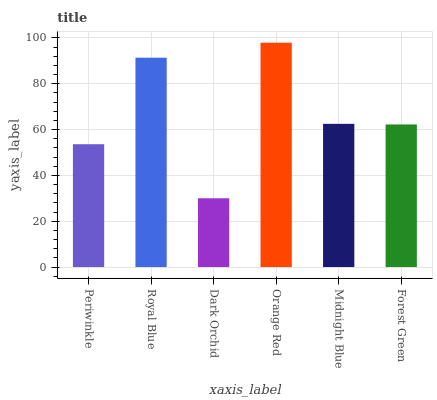Is Dark Orchid the minimum?
Answer yes or no. Yes. Is Orange Red the maximum?
Answer yes or no. Yes. Is Royal Blue the minimum?
Answer yes or no. No. Is Royal Blue the maximum?
Answer yes or no. No. Is Royal Blue greater than Periwinkle?
Answer yes or no. Yes. Is Periwinkle less than Royal Blue?
Answer yes or no. Yes. Is Periwinkle greater than Royal Blue?
Answer yes or no. No. Is Royal Blue less than Periwinkle?
Answer yes or no. No. Is Midnight Blue the high median?
Answer yes or no. Yes. Is Forest Green the low median?
Answer yes or no. Yes. Is Royal Blue the high median?
Answer yes or no. No. Is Dark Orchid the low median?
Answer yes or no. No. 